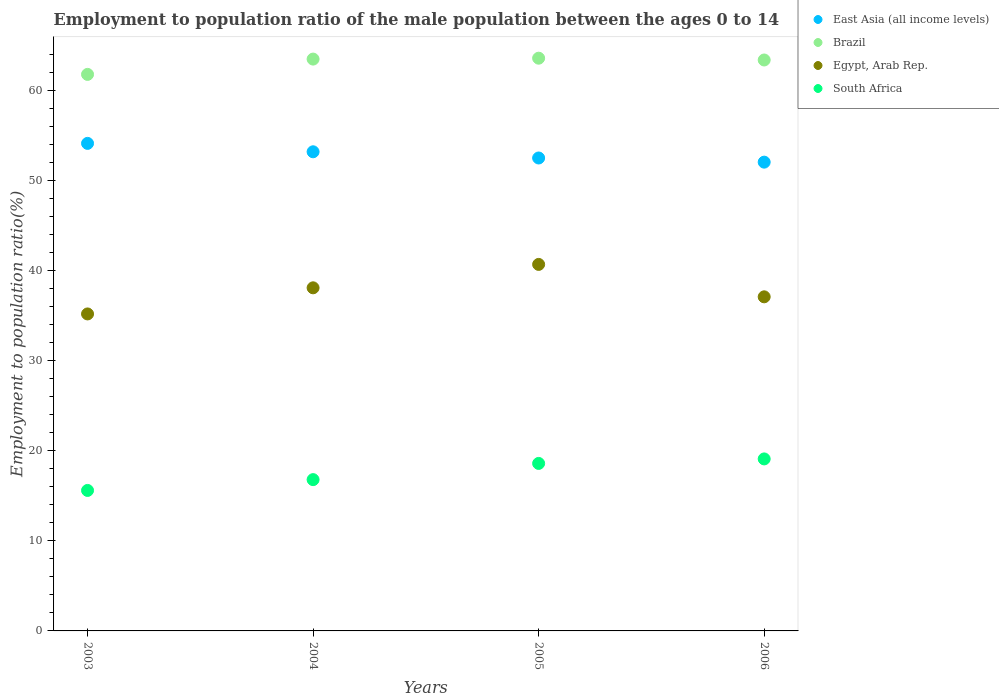How many different coloured dotlines are there?
Keep it short and to the point. 4. What is the employment to population ratio in Brazil in 2004?
Give a very brief answer. 63.5. Across all years, what is the maximum employment to population ratio in South Africa?
Your answer should be very brief. 19.1. Across all years, what is the minimum employment to population ratio in Brazil?
Provide a short and direct response. 61.8. In which year was the employment to population ratio in Brazil maximum?
Your answer should be very brief. 2005. In which year was the employment to population ratio in Brazil minimum?
Your answer should be compact. 2003. What is the total employment to population ratio in Egypt, Arab Rep. in the graph?
Provide a succinct answer. 151.1. What is the difference between the employment to population ratio in South Africa in 2005 and that in 2006?
Offer a terse response. -0.5. What is the difference between the employment to population ratio in East Asia (all income levels) in 2004 and the employment to population ratio in Egypt, Arab Rep. in 2003?
Make the answer very short. 18.01. What is the average employment to population ratio in Brazil per year?
Keep it short and to the point. 63.07. In the year 2005, what is the difference between the employment to population ratio in South Africa and employment to population ratio in East Asia (all income levels)?
Give a very brief answer. -33.92. What is the ratio of the employment to population ratio in Egypt, Arab Rep. in 2003 to that in 2004?
Your answer should be very brief. 0.92. Is the employment to population ratio in East Asia (all income levels) in 2003 less than that in 2004?
Offer a very short reply. No. Is the difference between the employment to population ratio in South Africa in 2003 and 2004 greater than the difference between the employment to population ratio in East Asia (all income levels) in 2003 and 2004?
Give a very brief answer. No. What is the difference between the highest and the second highest employment to population ratio in East Asia (all income levels)?
Your response must be concise. 0.93. Does the employment to population ratio in South Africa monotonically increase over the years?
Make the answer very short. Yes. Is the employment to population ratio in Brazil strictly greater than the employment to population ratio in East Asia (all income levels) over the years?
Offer a very short reply. Yes. Is the employment to population ratio in East Asia (all income levels) strictly less than the employment to population ratio in Brazil over the years?
Provide a succinct answer. Yes. How many dotlines are there?
Provide a short and direct response. 4. How many years are there in the graph?
Keep it short and to the point. 4. Are the values on the major ticks of Y-axis written in scientific E-notation?
Ensure brevity in your answer.  No. Does the graph contain grids?
Offer a terse response. No. Where does the legend appear in the graph?
Give a very brief answer. Top right. How many legend labels are there?
Provide a succinct answer. 4. What is the title of the graph?
Provide a succinct answer. Employment to population ratio of the male population between the ages 0 to 14. Does "Bahrain" appear as one of the legend labels in the graph?
Ensure brevity in your answer.  No. What is the label or title of the Y-axis?
Offer a very short reply. Employment to population ratio(%). What is the Employment to population ratio(%) in East Asia (all income levels) in 2003?
Your answer should be compact. 54.14. What is the Employment to population ratio(%) in Brazil in 2003?
Your response must be concise. 61.8. What is the Employment to population ratio(%) of Egypt, Arab Rep. in 2003?
Provide a succinct answer. 35.2. What is the Employment to population ratio(%) in South Africa in 2003?
Keep it short and to the point. 15.6. What is the Employment to population ratio(%) in East Asia (all income levels) in 2004?
Make the answer very short. 53.21. What is the Employment to population ratio(%) of Brazil in 2004?
Offer a terse response. 63.5. What is the Employment to population ratio(%) of Egypt, Arab Rep. in 2004?
Keep it short and to the point. 38.1. What is the Employment to population ratio(%) of South Africa in 2004?
Offer a very short reply. 16.8. What is the Employment to population ratio(%) of East Asia (all income levels) in 2005?
Provide a succinct answer. 52.52. What is the Employment to population ratio(%) of Brazil in 2005?
Provide a succinct answer. 63.6. What is the Employment to population ratio(%) in Egypt, Arab Rep. in 2005?
Provide a short and direct response. 40.7. What is the Employment to population ratio(%) in South Africa in 2005?
Provide a succinct answer. 18.6. What is the Employment to population ratio(%) of East Asia (all income levels) in 2006?
Provide a succinct answer. 52.06. What is the Employment to population ratio(%) of Brazil in 2006?
Your answer should be compact. 63.4. What is the Employment to population ratio(%) of Egypt, Arab Rep. in 2006?
Offer a terse response. 37.1. What is the Employment to population ratio(%) in South Africa in 2006?
Your answer should be compact. 19.1. Across all years, what is the maximum Employment to population ratio(%) in East Asia (all income levels)?
Give a very brief answer. 54.14. Across all years, what is the maximum Employment to population ratio(%) of Brazil?
Make the answer very short. 63.6. Across all years, what is the maximum Employment to population ratio(%) of Egypt, Arab Rep.?
Provide a succinct answer. 40.7. Across all years, what is the maximum Employment to population ratio(%) of South Africa?
Offer a terse response. 19.1. Across all years, what is the minimum Employment to population ratio(%) in East Asia (all income levels)?
Give a very brief answer. 52.06. Across all years, what is the minimum Employment to population ratio(%) of Brazil?
Make the answer very short. 61.8. Across all years, what is the minimum Employment to population ratio(%) of Egypt, Arab Rep.?
Provide a succinct answer. 35.2. Across all years, what is the minimum Employment to population ratio(%) in South Africa?
Offer a very short reply. 15.6. What is the total Employment to population ratio(%) of East Asia (all income levels) in the graph?
Keep it short and to the point. 211.92. What is the total Employment to population ratio(%) of Brazil in the graph?
Offer a very short reply. 252.3. What is the total Employment to population ratio(%) in Egypt, Arab Rep. in the graph?
Your answer should be very brief. 151.1. What is the total Employment to population ratio(%) of South Africa in the graph?
Offer a terse response. 70.1. What is the difference between the Employment to population ratio(%) of East Asia (all income levels) in 2003 and that in 2004?
Provide a short and direct response. 0.93. What is the difference between the Employment to population ratio(%) of Egypt, Arab Rep. in 2003 and that in 2004?
Ensure brevity in your answer.  -2.9. What is the difference between the Employment to population ratio(%) in East Asia (all income levels) in 2003 and that in 2005?
Give a very brief answer. 1.62. What is the difference between the Employment to population ratio(%) in Brazil in 2003 and that in 2005?
Give a very brief answer. -1.8. What is the difference between the Employment to population ratio(%) in East Asia (all income levels) in 2003 and that in 2006?
Give a very brief answer. 2.08. What is the difference between the Employment to population ratio(%) in South Africa in 2003 and that in 2006?
Give a very brief answer. -3.5. What is the difference between the Employment to population ratio(%) in East Asia (all income levels) in 2004 and that in 2005?
Give a very brief answer. 0.69. What is the difference between the Employment to population ratio(%) in Brazil in 2004 and that in 2005?
Ensure brevity in your answer.  -0.1. What is the difference between the Employment to population ratio(%) of Egypt, Arab Rep. in 2004 and that in 2005?
Your answer should be compact. -2.6. What is the difference between the Employment to population ratio(%) in East Asia (all income levels) in 2004 and that in 2006?
Your answer should be very brief. 1.15. What is the difference between the Employment to population ratio(%) of Brazil in 2004 and that in 2006?
Offer a terse response. 0.1. What is the difference between the Employment to population ratio(%) of East Asia (all income levels) in 2005 and that in 2006?
Give a very brief answer. 0.46. What is the difference between the Employment to population ratio(%) of Brazil in 2005 and that in 2006?
Your answer should be compact. 0.2. What is the difference between the Employment to population ratio(%) in Egypt, Arab Rep. in 2005 and that in 2006?
Your response must be concise. 3.6. What is the difference between the Employment to population ratio(%) of South Africa in 2005 and that in 2006?
Your response must be concise. -0.5. What is the difference between the Employment to population ratio(%) of East Asia (all income levels) in 2003 and the Employment to population ratio(%) of Brazil in 2004?
Ensure brevity in your answer.  -9.36. What is the difference between the Employment to population ratio(%) in East Asia (all income levels) in 2003 and the Employment to population ratio(%) in Egypt, Arab Rep. in 2004?
Offer a terse response. 16.04. What is the difference between the Employment to population ratio(%) of East Asia (all income levels) in 2003 and the Employment to population ratio(%) of South Africa in 2004?
Your response must be concise. 37.34. What is the difference between the Employment to population ratio(%) of Brazil in 2003 and the Employment to population ratio(%) of Egypt, Arab Rep. in 2004?
Give a very brief answer. 23.7. What is the difference between the Employment to population ratio(%) in Egypt, Arab Rep. in 2003 and the Employment to population ratio(%) in South Africa in 2004?
Provide a short and direct response. 18.4. What is the difference between the Employment to population ratio(%) in East Asia (all income levels) in 2003 and the Employment to population ratio(%) in Brazil in 2005?
Your answer should be very brief. -9.46. What is the difference between the Employment to population ratio(%) in East Asia (all income levels) in 2003 and the Employment to population ratio(%) in Egypt, Arab Rep. in 2005?
Offer a terse response. 13.44. What is the difference between the Employment to population ratio(%) in East Asia (all income levels) in 2003 and the Employment to population ratio(%) in South Africa in 2005?
Your response must be concise. 35.54. What is the difference between the Employment to population ratio(%) in Brazil in 2003 and the Employment to population ratio(%) in Egypt, Arab Rep. in 2005?
Your response must be concise. 21.1. What is the difference between the Employment to population ratio(%) in Brazil in 2003 and the Employment to population ratio(%) in South Africa in 2005?
Provide a succinct answer. 43.2. What is the difference between the Employment to population ratio(%) in Egypt, Arab Rep. in 2003 and the Employment to population ratio(%) in South Africa in 2005?
Provide a short and direct response. 16.6. What is the difference between the Employment to population ratio(%) of East Asia (all income levels) in 2003 and the Employment to population ratio(%) of Brazil in 2006?
Your answer should be very brief. -9.26. What is the difference between the Employment to population ratio(%) in East Asia (all income levels) in 2003 and the Employment to population ratio(%) in Egypt, Arab Rep. in 2006?
Ensure brevity in your answer.  17.04. What is the difference between the Employment to population ratio(%) in East Asia (all income levels) in 2003 and the Employment to population ratio(%) in South Africa in 2006?
Offer a terse response. 35.04. What is the difference between the Employment to population ratio(%) in Brazil in 2003 and the Employment to population ratio(%) in Egypt, Arab Rep. in 2006?
Your answer should be very brief. 24.7. What is the difference between the Employment to population ratio(%) of Brazil in 2003 and the Employment to population ratio(%) of South Africa in 2006?
Give a very brief answer. 42.7. What is the difference between the Employment to population ratio(%) of East Asia (all income levels) in 2004 and the Employment to population ratio(%) of Brazil in 2005?
Your response must be concise. -10.39. What is the difference between the Employment to population ratio(%) of East Asia (all income levels) in 2004 and the Employment to population ratio(%) of Egypt, Arab Rep. in 2005?
Your response must be concise. 12.51. What is the difference between the Employment to population ratio(%) of East Asia (all income levels) in 2004 and the Employment to population ratio(%) of South Africa in 2005?
Keep it short and to the point. 34.61. What is the difference between the Employment to population ratio(%) of Brazil in 2004 and the Employment to population ratio(%) of Egypt, Arab Rep. in 2005?
Provide a short and direct response. 22.8. What is the difference between the Employment to population ratio(%) of Brazil in 2004 and the Employment to population ratio(%) of South Africa in 2005?
Your answer should be very brief. 44.9. What is the difference between the Employment to population ratio(%) of East Asia (all income levels) in 2004 and the Employment to population ratio(%) of Brazil in 2006?
Provide a succinct answer. -10.19. What is the difference between the Employment to population ratio(%) of East Asia (all income levels) in 2004 and the Employment to population ratio(%) of Egypt, Arab Rep. in 2006?
Your answer should be compact. 16.11. What is the difference between the Employment to population ratio(%) of East Asia (all income levels) in 2004 and the Employment to population ratio(%) of South Africa in 2006?
Your answer should be very brief. 34.11. What is the difference between the Employment to population ratio(%) in Brazil in 2004 and the Employment to population ratio(%) in Egypt, Arab Rep. in 2006?
Your response must be concise. 26.4. What is the difference between the Employment to population ratio(%) of Brazil in 2004 and the Employment to population ratio(%) of South Africa in 2006?
Your answer should be very brief. 44.4. What is the difference between the Employment to population ratio(%) of Egypt, Arab Rep. in 2004 and the Employment to population ratio(%) of South Africa in 2006?
Provide a succinct answer. 19. What is the difference between the Employment to population ratio(%) in East Asia (all income levels) in 2005 and the Employment to population ratio(%) in Brazil in 2006?
Provide a short and direct response. -10.88. What is the difference between the Employment to population ratio(%) of East Asia (all income levels) in 2005 and the Employment to population ratio(%) of Egypt, Arab Rep. in 2006?
Ensure brevity in your answer.  15.42. What is the difference between the Employment to population ratio(%) in East Asia (all income levels) in 2005 and the Employment to population ratio(%) in South Africa in 2006?
Give a very brief answer. 33.42. What is the difference between the Employment to population ratio(%) in Brazil in 2005 and the Employment to population ratio(%) in South Africa in 2006?
Your answer should be compact. 44.5. What is the difference between the Employment to population ratio(%) of Egypt, Arab Rep. in 2005 and the Employment to population ratio(%) of South Africa in 2006?
Your response must be concise. 21.6. What is the average Employment to population ratio(%) in East Asia (all income levels) per year?
Make the answer very short. 52.98. What is the average Employment to population ratio(%) in Brazil per year?
Ensure brevity in your answer.  63.08. What is the average Employment to population ratio(%) in Egypt, Arab Rep. per year?
Ensure brevity in your answer.  37.77. What is the average Employment to population ratio(%) in South Africa per year?
Keep it short and to the point. 17.52. In the year 2003, what is the difference between the Employment to population ratio(%) in East Asia (all income levels) and Employment to population ratio(%) in Brazil?
Your answer should be compact. -7.66. In the year 2003, what is the difference between the Employment to population ratio(%) in East Asia (all income levels) and Employment to population ratio(%) in Egypt, Arab Rep.?
Your answer should be compact. 18.94. In the year 2003, what is the difference between the Employment to population ratio(%) in East Asia (all income levels) and Employment to population ratio(%) in South Africa?
Your response must be concise. 38.54. In the year 2003, what is the difference between the Employment to population ratio(%) in Brazil and Employment to population ratio(%) in Egypt, Arab Rep.?
Keep it short and to the point. 26.6. In the year 2003, what is the difference between the Employment to population ratio(%) in Brazil and Employment to population ratio(%) in South Africa?
Ensure brevity in your answer.  46.2. In the year 2003, what is the difference between the Employment to population ratio(%) in Egypt, Arab Rep. and Employment to population ratio(%) in South Africa?
Ensure brevity in your answer.  19.6. In the year 2004, what is the difference between the Employment to population ratio(%) of East Asia (all income levels) and Employment to population ratio(%) of Brazil?
Provide a succinct answer. -10.29. In the year 2004, what is the difference between the Employment to population ratio(%) in East Asia (all income levels) and Employment to population ratio(%) in Egypt, Arab Rep.?
Give a very brief answer. 15.11. In the year 2004, what is the difference between the Employment to population ratio(%) in East Asia (all income levels) and Employment to population ratio(%) in South Africa?
Ensure brevity in your answer.  36.41. In the year 2004, what is the difference between the Employment to population ratio(%) of Brazil and Employment to population ratio(%) of Egypt, Arab Rep.?
Make the answer very short. 25.4. In the year 2004, what is the difference between the Employment to population ratio(%) of Brazil and Employment to population ratio(%) of South Africa?
Your answer should be very brief. 46.7. In the year 2004, what is the difference between the Employment to population ratio(%) of Egypt, Arab Rep. and Employment to population ratio(%) of South Africa?
Offer a very short reply. 21.3. In the year 2005, what is the difference between the Employment to population ratio(%) in East Asia (all income levels) and Employment to population ratio(%) in Brazil?
Give a very brief answer. -11.08. In the year 2005, what is the difference between the Employment to population ratio(%) of East Asia (all income levels) and Employment to population ratio(%) of Egypt, Arab Rep.?
Ensure brevity in your answer.  11.82. In the year 2005, what is the difference between the Employment to population ratio(%) of East Asia (all income levels) and Employment to population ratio(%) of South Africa?
Give a very brief answer. 33.92. In the year 2005, what is the difference between the Employment to population ratio(%) of Brazil and Employment to population ratio(%) of Egypt, Arab Rep.?
Your answer should be compact. 22.9. In the year 2005, what is the difference between the Employment to population ratio(%) of Brazil and Employment to population ratio(%) of South Africa?
Offer a very short reply. 45. In the year 2005, what is the difference between the Employment to population ratio(%) in Egypt, Arab Rep. and Employment to population ratio(%) in South Africa?
Your answer should be compact. 22.1. In the year 2006, what is the difference between the Employment to population ratio(%) of East Asia (all income levels) and Employment to population ratio(%) of Brazil?
Your answer should be compact. -11.34. In the year 2006, what is the difference between the Employment to population ratio(%) in East Asia (all income levels) and Employment to population ratio(%) in Egypt, Arab Rep.?
Provide a succinct answer. 14.96. In the year 2006, what is the difference between the Employment to population ratio(%) of East Asia (all income levels) and Employment to population ratio(%) of South Africa?
Keep it short and to the point. 32.96. In the year 2006, what is the difference between the Employment to population ratio(%) in Brazil and Employment to population ratio(%) in Egypt, Arab Rep.?
Your answer should be very brief. 26.3. In the year 2006, what is the difference between the Employment to population ratio(%) of Brazil and Employment to population ratio(%) of South Africa?
Provide a succinct answer. 44.3. In the year 2006, what is the difference between the Employment to population ratio(%) in Egypt, Arab Rep. and Employment to population ratio(%) in South Africa?
Offer a terse response. 18. What is the ratio of the Employment to population ratio(%) of East Asia (all income levels) in 2003 to that in 2004?
Provide a succinct answer. 1.02. What is the ratio of the Employment to population ratio(%) in Brazil in 2003 to that in 2004?
Offer a terse response. 0.97. What is the ratio of the Employment to population ratio(%) of Egypt, Arab Rep. in 2003 to that in 2004?
Provide a succinct answer. 0.92. What is the ratio of the Employment to population ratio(%) of South Africa in 2003 to that in 2004?
Your answer should be very brief. 0.93. What is the ratio of the Employment to population ratio(%) in East Asia (all income levels) in 2003 to that in 2005?
Offer a very short reply. 1.03. What is the ratio of the Employment to population ratio(%) in Brazil in 2003 to that in 2005?
Make the answer very short. 0.97. What is the ratio of the Employment to population ratio(%) in Egypt, Arab Rep. in 2003 to that in 2005?
Offer a very short reply. 0.86. What is the ratio of the Employment to population ratio(%) of South Africa in 2003 to that in 2005?
Keep it short and to the point. 0.84. What is the ratio of the Employment to population ratio(%) in Brazil in 2003 to that in 2006?
Provide a succinct answer. 0.97. What is the ratio of the Employment to population ratio(%) in Egypt, Arab Rep. in 2003 to that in 2006?
Provide a short and direct response. 0.95. What is the ratio of the Employment to population ratio(%) in South Africa in 2003 to that in 2006?
Your response must be concise. 0.82. What is the ratio of the Employment to population ratio(%) of East Asia (all income levels) in 2004 to that in 2005?
Offer a terse response. 1.01. What is the ratio of the Employment to population ratio(%) in Egypt, Arab Rep. in 2004 to that in 2005?
Offer a very short reply. 0.94. What is the ratio of the Employment to population ratio(%) in South Africa in 2004 to that in 2005?
Offer a terse response. 0.9. What is the ratio of the Employment to population ratio(%) of East Asia (all income levels) in 2004 to that in 2006?
Provide a succinct answer. 1.02. What is the ratio of the Employment to population ratio(%) in South Africa in 2004 to that in 2006?
Give a very brief answer. 0.88. What is the ratio of the Employment to population ratio(%) of East Asia (all income levels) in 2005 to that in 2006?
Make the answer very short. 1.01. What is the ratio of the Employment to population ratio(%) in Egypt, Arab Rep. in 2005 to that in 2006?
Offer a terse response. 1.1. What is the ratio of the Employment to population ratio(%) of South Africa in 2005 to that in 2006?
Your answer should be compact. 0.97. What is the difference between the highest and the second highest Employment to population ratio(%) of East Asia (all income levels)?
Provide a short and direct response. 0.93. What is the difference between the highest and the second highest Employment to population ratio(%) in Brazil?
Provide a succinct answer. 0.1. What is the difference between the highest and the second highest Employment to population ratio(%) of South Africa?
Your answer should be compact. 0.5. What is the difference between the highest and the lowest Employment to population ratio(%) in East Asia (all income levels)?
Offer a terse response. 2.08. What is the difference between the highest and the lowest Employment to population ratio(%) of Egypt, Arab Rep.?
Make the answer very short. 5.5. What is the difference between the highest and the lowest Employment to population ratio(%) of South Africa?
Provide a succinct answer. 3.5. 